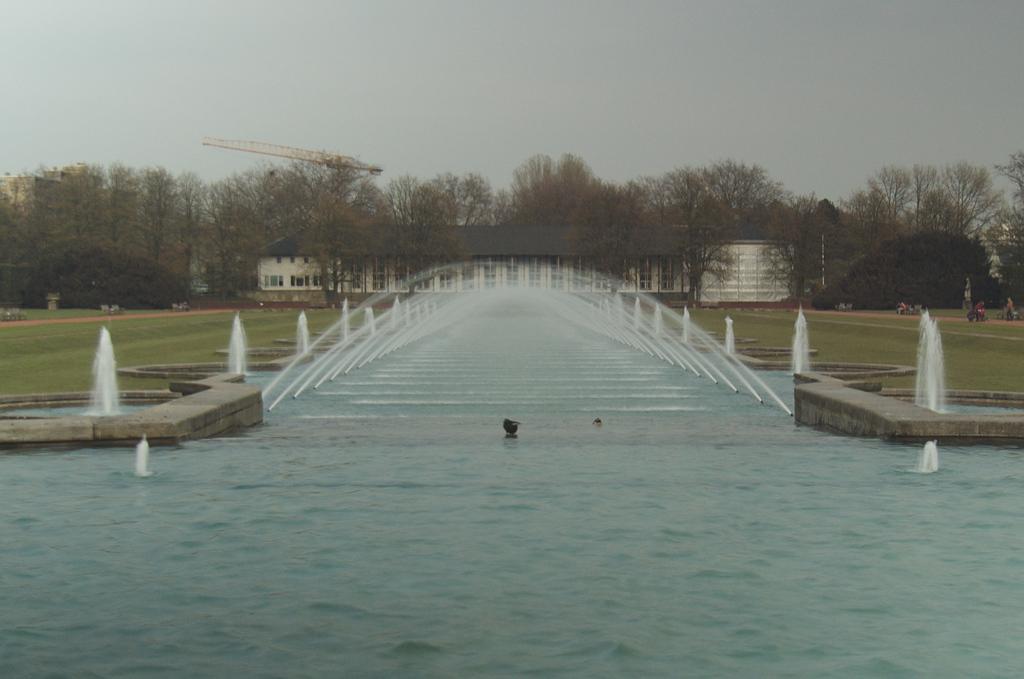How would you summarize this image in a sentence or two? This image consists of water. At the bottom, there is water. In the front, there is fountain. In the background, there is a building along with many trees. At the top, there is sky. And we can see green grass on the ground. 